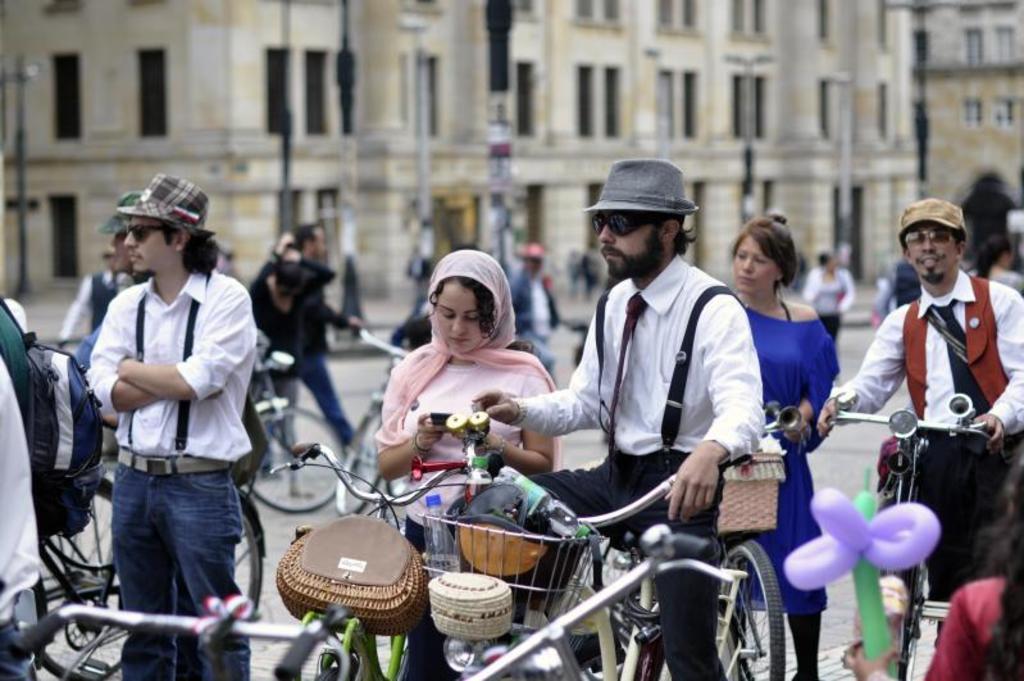In one or two sentences, can you explain what this image depicts? In this image we can see a person sitting on a bicycle and he is in the center. There is another person who is on the right side and he is also holding a bicycle. In the background we can see a few people who are walking on a road and a building. 